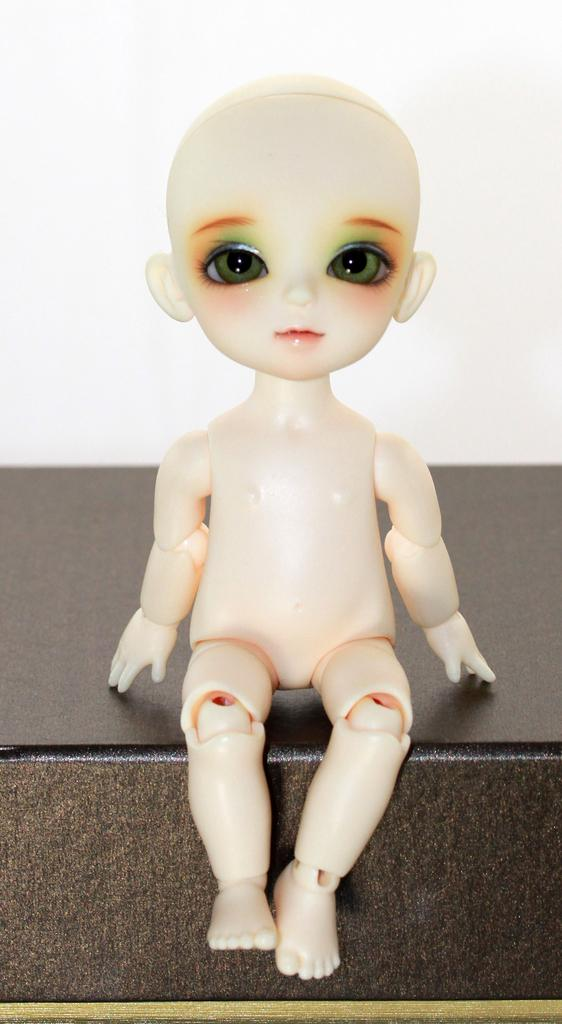What is the main subject of the image? There is a doll in the image. Can you describe the appearance of the doll? The doll is white in color. What type of comfort does the pickle provide in the image? There is no pickle present in the image, so it cannot provide any comfort. 